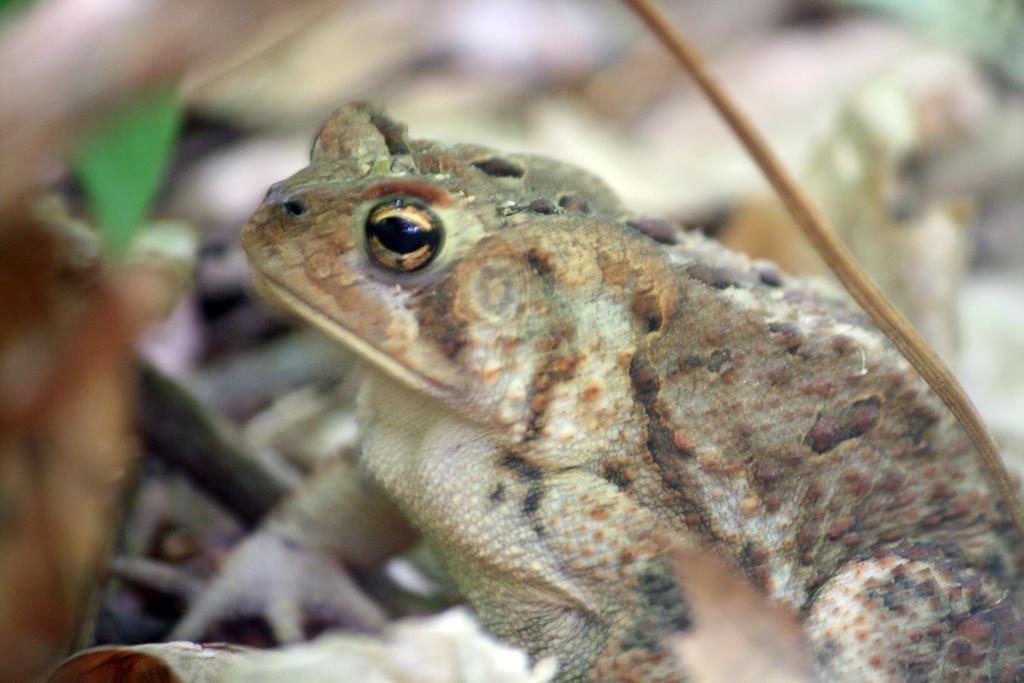In one or two sentences, can you explain what this image depicts? In this image I can see a frog which is facing towards the left side. The background is blurred. 